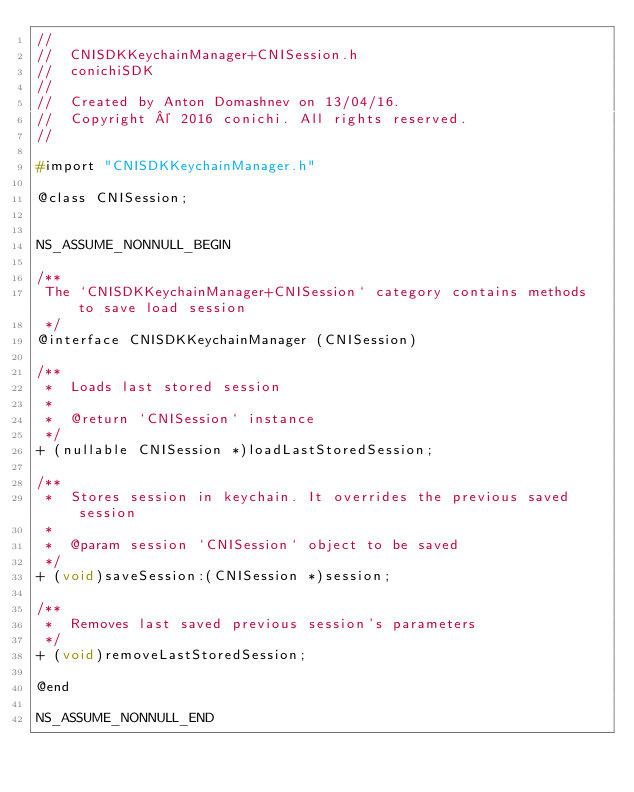<code> <loc_0><loc_0><loc_500><loc_500><_C_>//
//  CNISDKKeychainManager+CNISession.h
//  conichiSDK
//
//  Created by Anton Domashnev on 13/04/16.
//  Copyright © 2016 conichi. All rights reserved.
//

#import "CNISDKKeychainManager.h"

@class CNISession;


NS_ASSUME_NONNULL_BEGIN

/**
 The `CNISDKKeychainManager+CNISession` category contains methods to save load session
 */
@interface CNISDKKeychainManager (CNISession)

/**
 *  Loads last stored session
 *
 *  @return `CNISession` instance
 */
+ (nullable CNISession *)loadLastStoredSession;

/**
 *  Stores session in keychain. It overrides the previous saved session
 *
 *  @param session `CNISession` object to be saved
 */
+ (void)saveSession:(CNISession *)session;

/**
 *  Removes last saved previous session's parameters
 */
+ (void)removeLastStoredSession;

@end

NS_ASSUME_NONNULL_END
</code> 